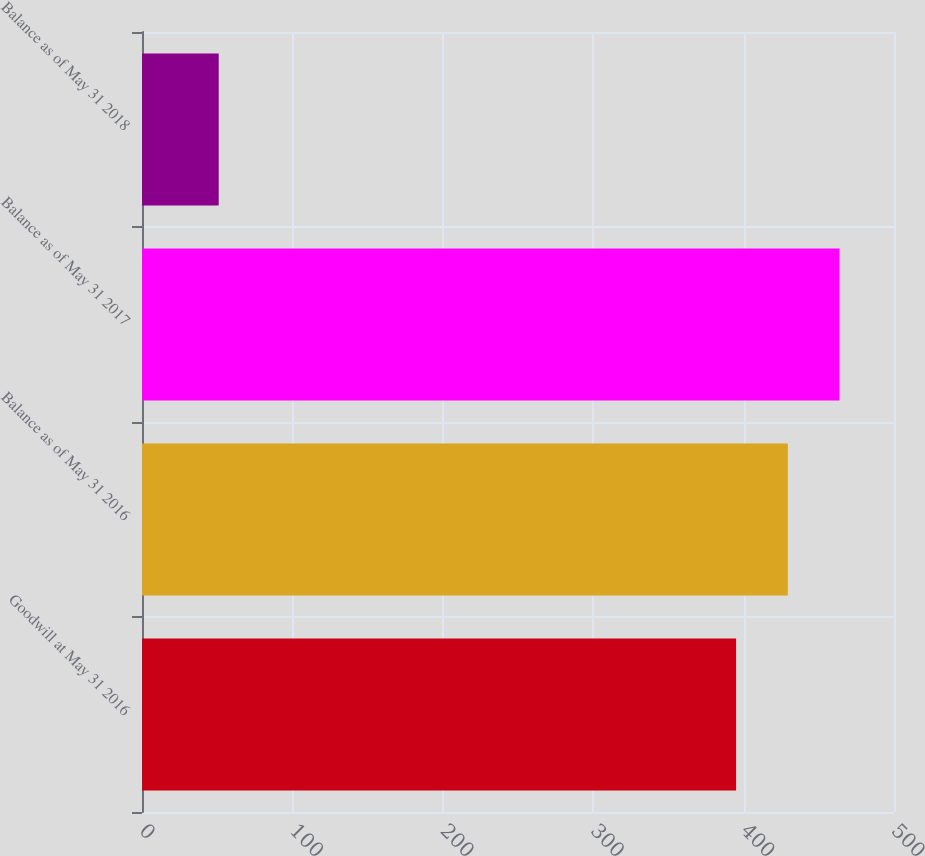<chart> <loc_0><loc_0><loc_500><loc_500><bar_chart><fcel>Goodwill at May 31 2016<fcel>Balance as of May 31 2016<fcel>Balance as of May 31 2017<fcel>Balance as of May 31 2018<nl><fcel>395<fcel>429.4<fcel>463.8<fcel>51<nl></chart> 